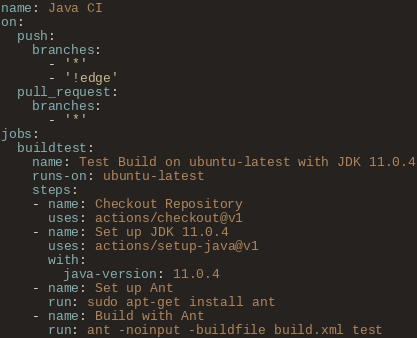Convert code to text. <code><loc_0><loc_0><loc_500><loc_500><_YAML_>name: Java CI
on:
  push:
    branches:
      - '*'
      - '!edge'
  pull_request:
    branches:
      - '*'
jobs:
  buildtest:
    name: Test Build on ubuntu-latest with JDK 11.0.4
    runs-on: ubuntu-latest
    steps:
    - name: Checkout Repository
      uses: actions/checkout@v1
    - name: Set up JDK 11.0.4
      uses: actions/setup-java@v1
      with:
        java-version: 11.0.4
    - name: Set up Ant
      run: sudo apt-get install ant
    - name: Build with Ant
      run: ant -noinput -buildfile build.xml test</code> 